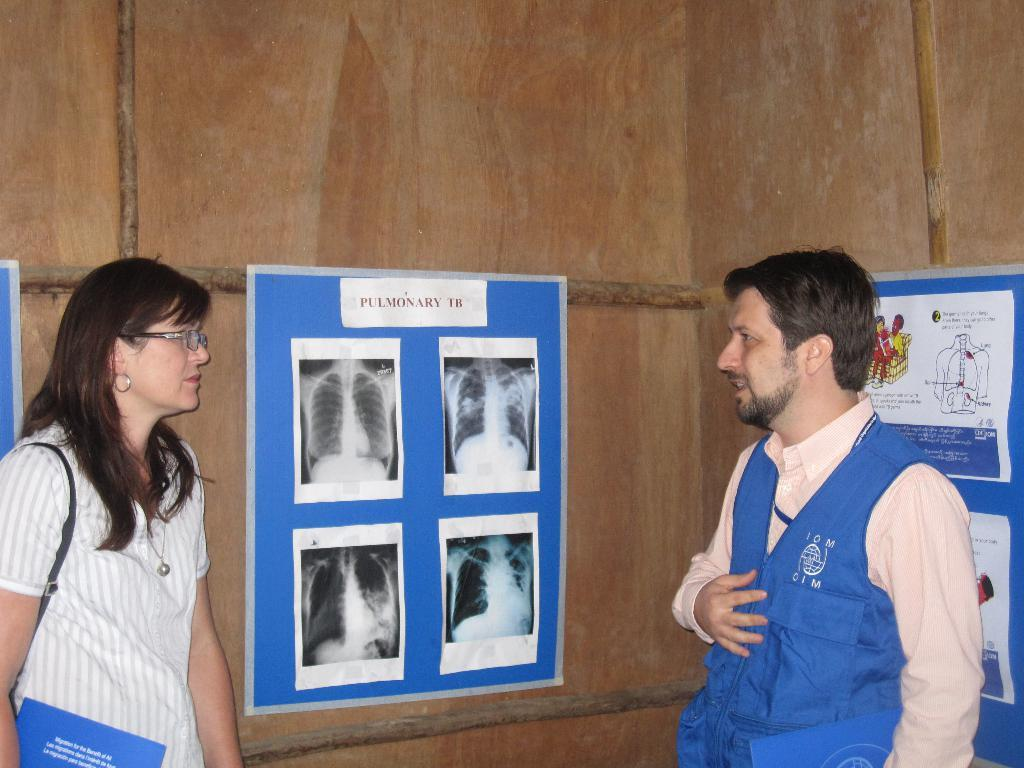How many people are in the image? There are two persons standing in the image. Can you describe one of the persons? One of the persons is a woman. What is the woman holding or carrying in the image? The woman is carrying a bag. What can be seen in the background of the image? There are posts on a wooden wall in the background of the image. What type of bean is growing on the wooden wall in the image? There are no beans present in the image, and the wooden wall does not have any plants growing on it. 